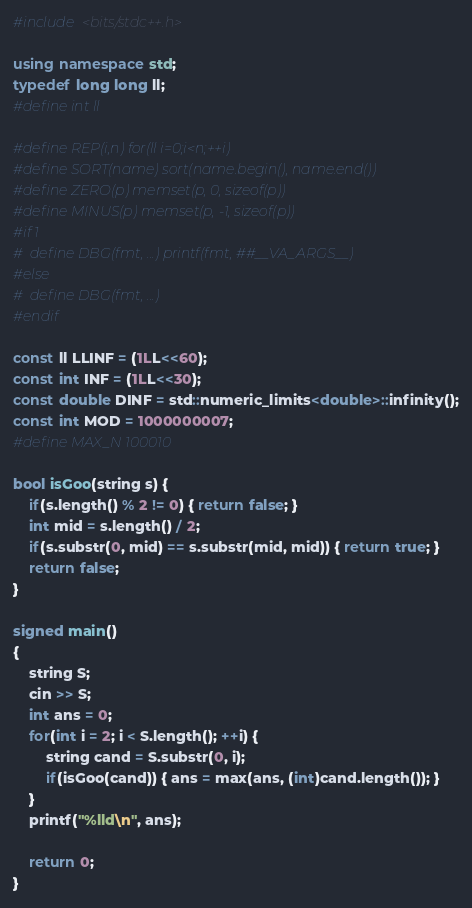Convert code to text. <code><loc_0><loc_0><loc_500><loc_500><_C++_>#include <bits/stdc++.h>

using namespace std;
typedef long long ll;
#define int ll

#define REP(i,n) for(ll i=0;i<n;++i)
#define SORT(name) sort(name.begin(), name.end())
#define ZERO(p) memset(p, 0, sizeof(p))
#define MINUS(p) memset(p, -1, sizeof(p))
#if 1
#  define DBG(fmt, ...) printf(fmt, ##__VA_ARGS__)
#else
#  define DBG(fmt, ...)
#endif

const ll LLINF = (1LL<<60);
const int INF = (1LL<<30);
const double DINF = std::numeric_limits<double>::infinity();
const int MOD = 1000000007;
#define MAX_N 100010

bool isGoo(string s) {
    if(s.length() % 2 != 0) { return false; }
    int mid = s.length() / 2;
    if(s.substr(0, mid) == s.substr(mid, mid)) { return true; }
    return false;
}

signed main()
{
    string S;
    cin >> S;
    int ans = 0;
    for(int i = 2; i < S.length(); ++i) {
        string cand = S.substr(0, i);
        if(isGoo(cand)) { ans = max(ans, (int)cand.length()); }
    }
    printf("%lld\n", ans);

    return 0;
}
</code> 